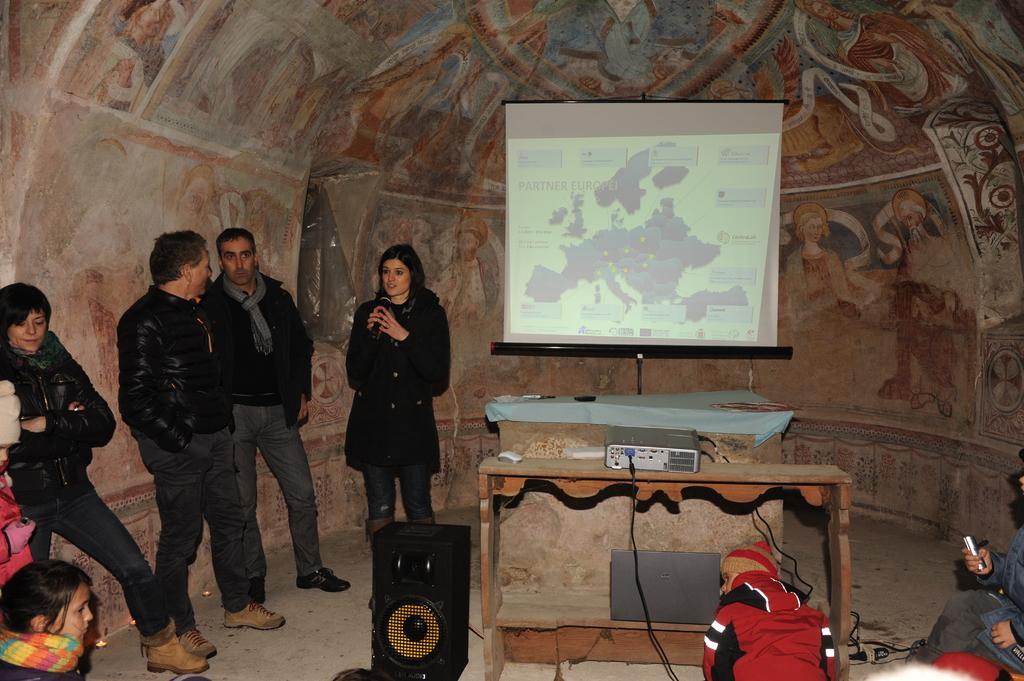How would you summarize this image in a sentence or two? there are people standing. at the center there are projector display. in front of it there is a table on which projector is kept. to its left there is a speaker. 